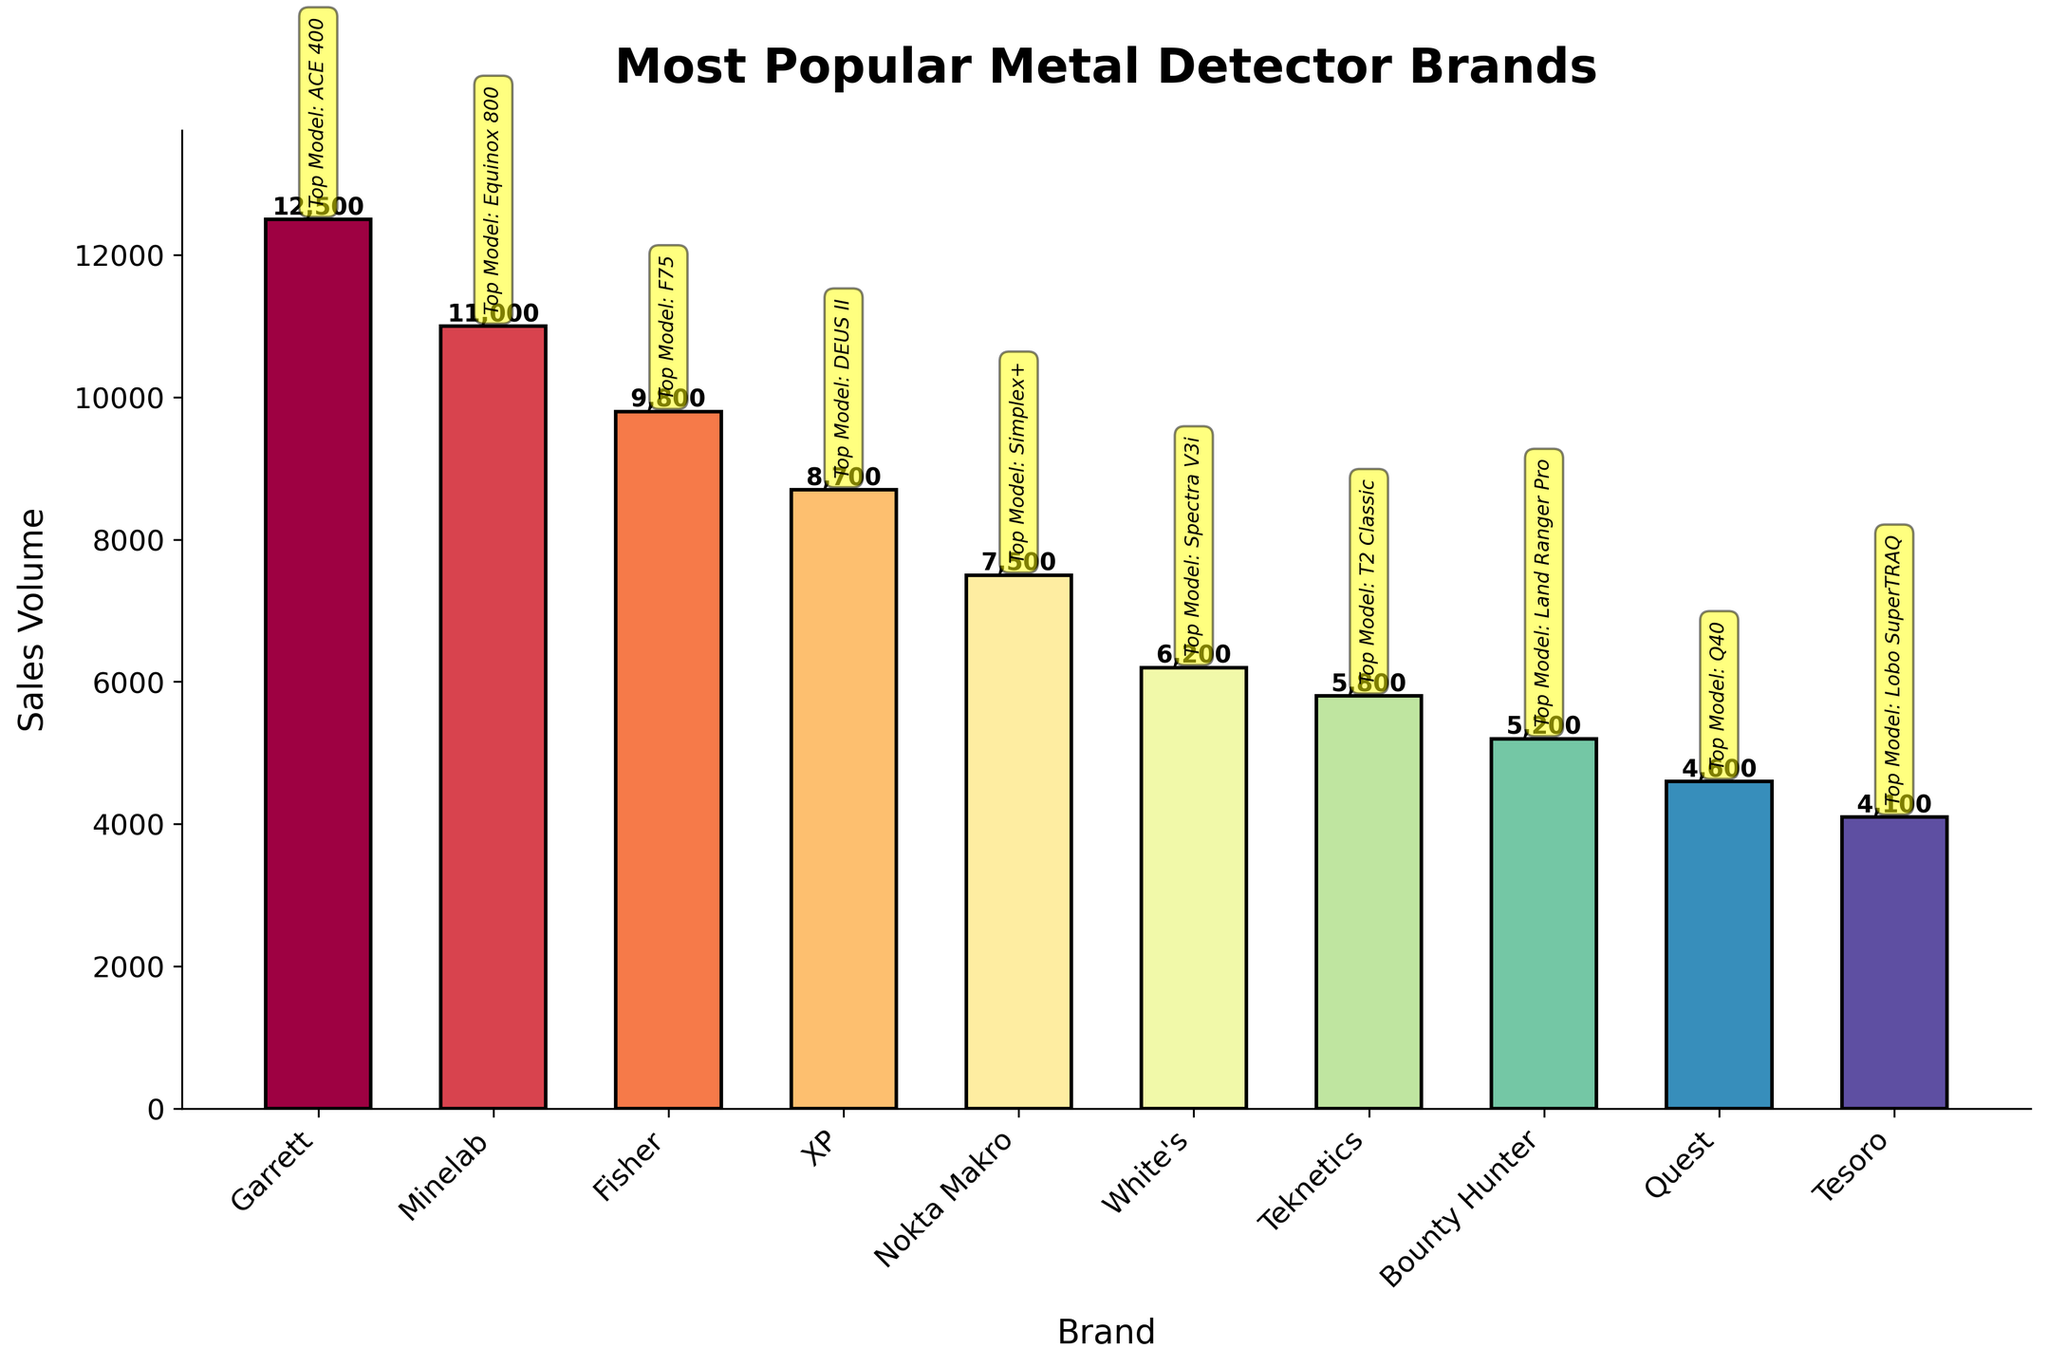Which brand has the highest sales volume? The brand with the tallest bar in the chart represents the highest sales volume. The tallest bar belongs to Garrett.
Answer: Garrett Which brand has the second highest sales volume? To find the second highest sales volume, look for the second tallest bar in the chart. The second tallest bar belongs to Minelab.
Answer: Minelab How many more units did Garrett sell compared to Teknetics? Identify the sales volumes for Garrett and Teknetics from the chart. Garrett sold 12,500 units, and Teknetics sold 5,800 units. Subtract Teknetics' sales from Garrett's sales: 12,500 - 5,800 = 6,700.
Answer: 6,700 What is the combined sales volume of Fisher and XP? Identify the sales volumes from the chart: Fisher sold 9,800 units and XP sold 8,700 units. Sum their sales: 9,800 + 8,700 = 18,500.
Answer: 18,500 Which brand's best-selling model is the "Simplex+"? From the chart annotations, find the bar labeled "Top Model: Simplex+". This model is highlighted for the brand Nokta Makro.
Answer: Nokta Makro Which brand has the smallest sales volume? The brand with the shortest bar in the chart represents the smallest sales volume. The shortest bar belongs to Tesoro.
Answer: Tesoro Is the sales volume of Minelab greater than the combined sales of Quest and Tesoro? Find the sales volumes of Minelab (11,000 units), Quest (4,600 units), and Tesoro (4,100 units). Sum the sales of Quest and Tesoro: 4,600 + 4,100 = 8,700 units. Compare this with Minelab's sales: 11,000 > 8,700.
Answer: Yes Which brand is just below Fisher in sales volume? In the chart ordered by descending sales volume, find Fisher (9,800 units). The brand just below Fisher is XP (8,700 units).
Answer: XP What is the average sales volume of all the brands? Sum the sales volumes of all brands and divide by the number of brands. Total sales = 12,500 + 11,000 + 9,800 + 8,700 + 7,500 + 6,200 + 5,800 + 5,200 + 4,600 + 4,100 = 75,400 units. There are 10 brands. Average = 75,400 / 10 = 7,540 units.
Answer: 7,540 Which brand's best-selling model is the "Equinox 800"? From the chart annotations, find the bar labeled "Top Model: Equinox 800". This model is highlighted for the brand Minelab.
Answer: Minelab 